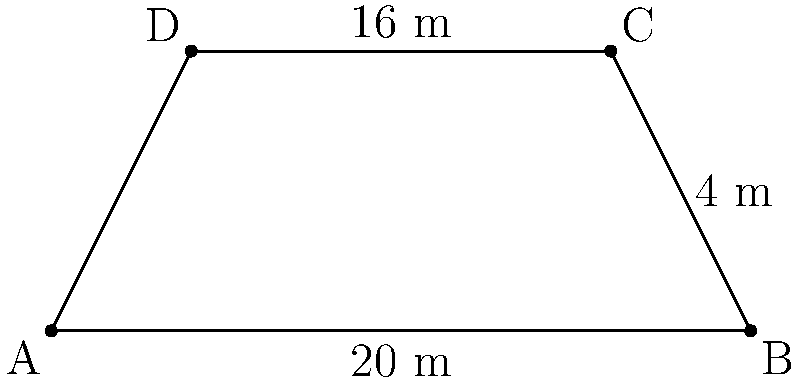At the Kentucky Derby, a new trapezoidal viewing stand is being constructed. The stand's base measures 20 meters, its top measures 16 meters, and it has a height of 4 meters. As a jockey familiar with racetrack layouts, calculate the area of this viewing stand in square meters. To find the area of the trapezoidal viewing stand, we'll use the formula for the area of a trapezoid:

$$A = \frac{1}{2}(b_1 + b_2)h$$

Where:
$A$ = Area
$b_1$ = Length of one parallel side (base)
$b_2$ = Length of the other parallel side (top)
$h$ = Height (perpendicular distance between parallel sides)

Given:
$b_1 = 20$ meters (base)
$b_2 = 16$ meters (top)
$h = 4$ meters (height)

Let's substitute these values into the formula:

$$A = \frac{1}{2}(20 + 16) \times 4$$

$$A = \frac{1}{2}(36) \times 4$$

$$A = 18 \times 4$$

$$A = 72$$

Therefore, the area of the trapezoidal viewing stand is 72 square meters.
Answer: 72 m² 